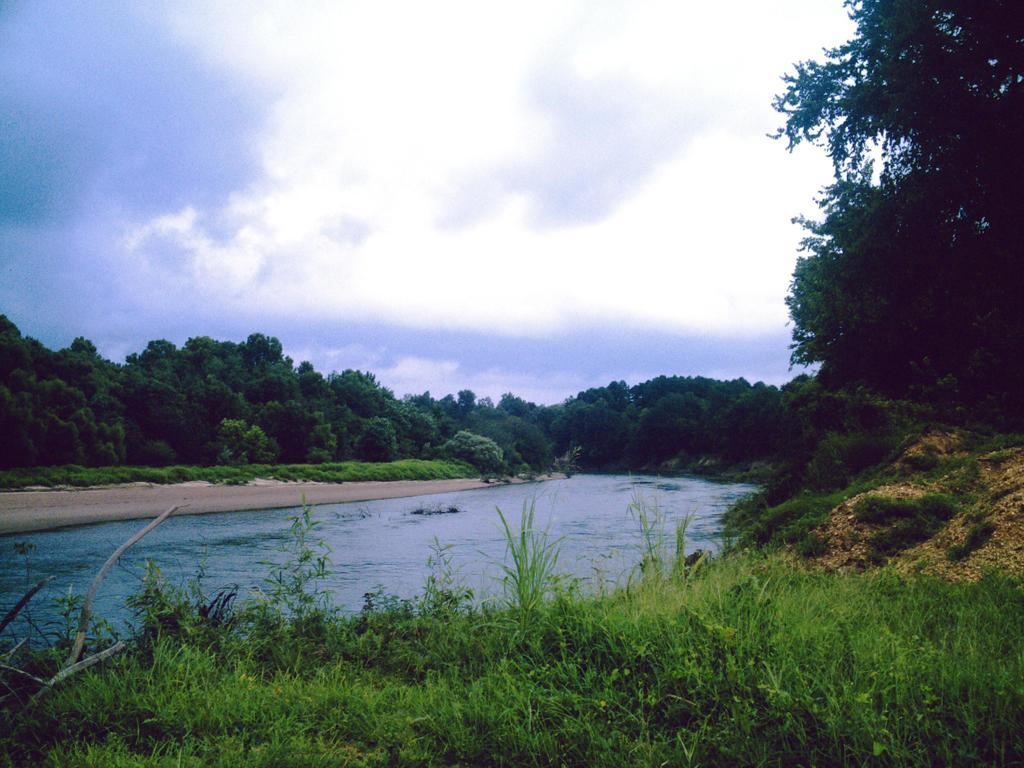What type of vegetation can be seen in the image? There are trees in the image. What natural element is visible in the image besides trees? There is water visible in the image. What type of ground cover is present at the bottom of the image? There is grass at the bottom of the image. What is the condition of the sky in the image? The sky is cloudy and visible at the top of the image. Can you see a feather floating on the water in the image? There is no feather visible in the image; it only features trees, water, grass, and a cloudy sky. 